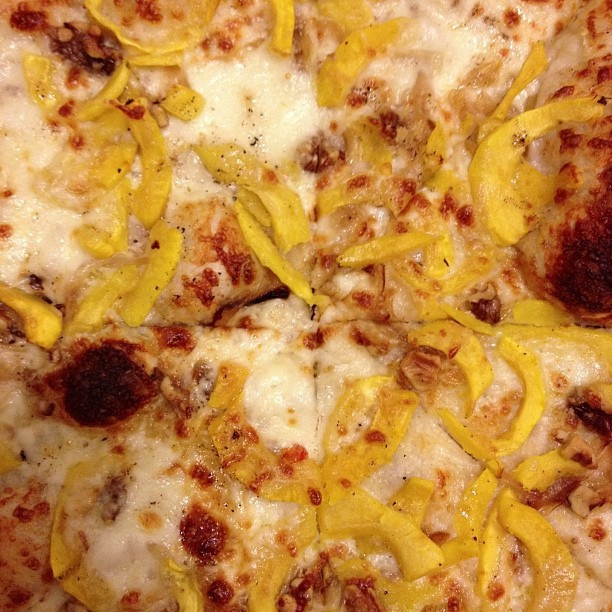Describe the objects in this image and their specific colors. I can see a pizza in orange, tan, red, and maroon tones in this image. 